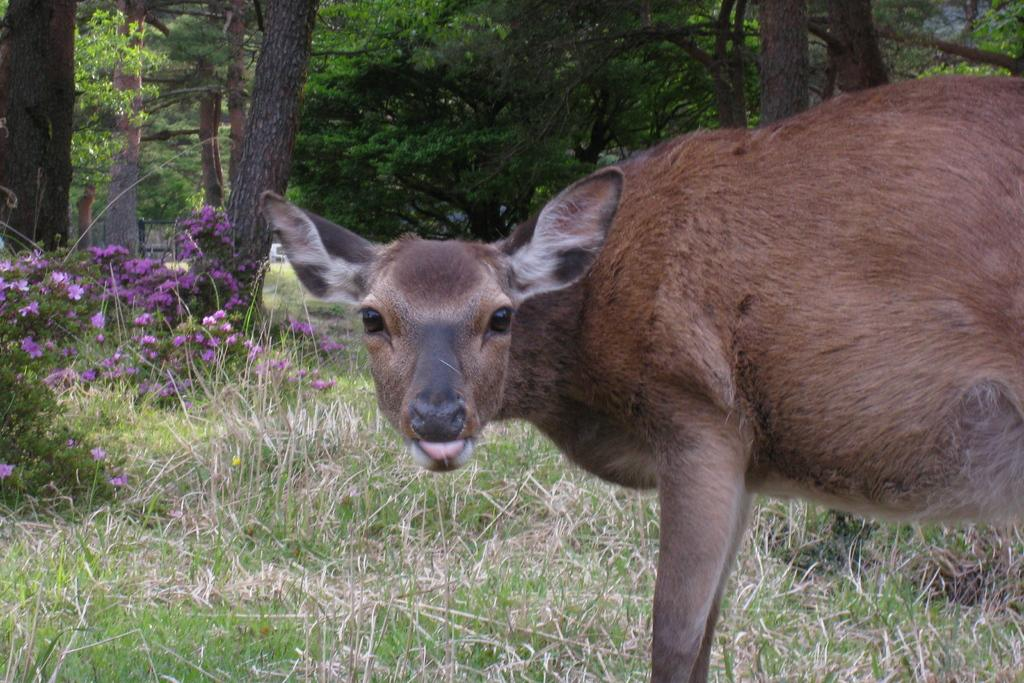What type of animal can be seen in the image? There is a brown color animal in the image. What is the ground covered with in the image? There is grass and flowers on the ground in the image. What can be seen in the background of the image? There are trees in the background of the image. Where is the airport located in the image? There is no airport present in the image. What type of meeting is taking place in the image? There is no meeting depicted in the image. 